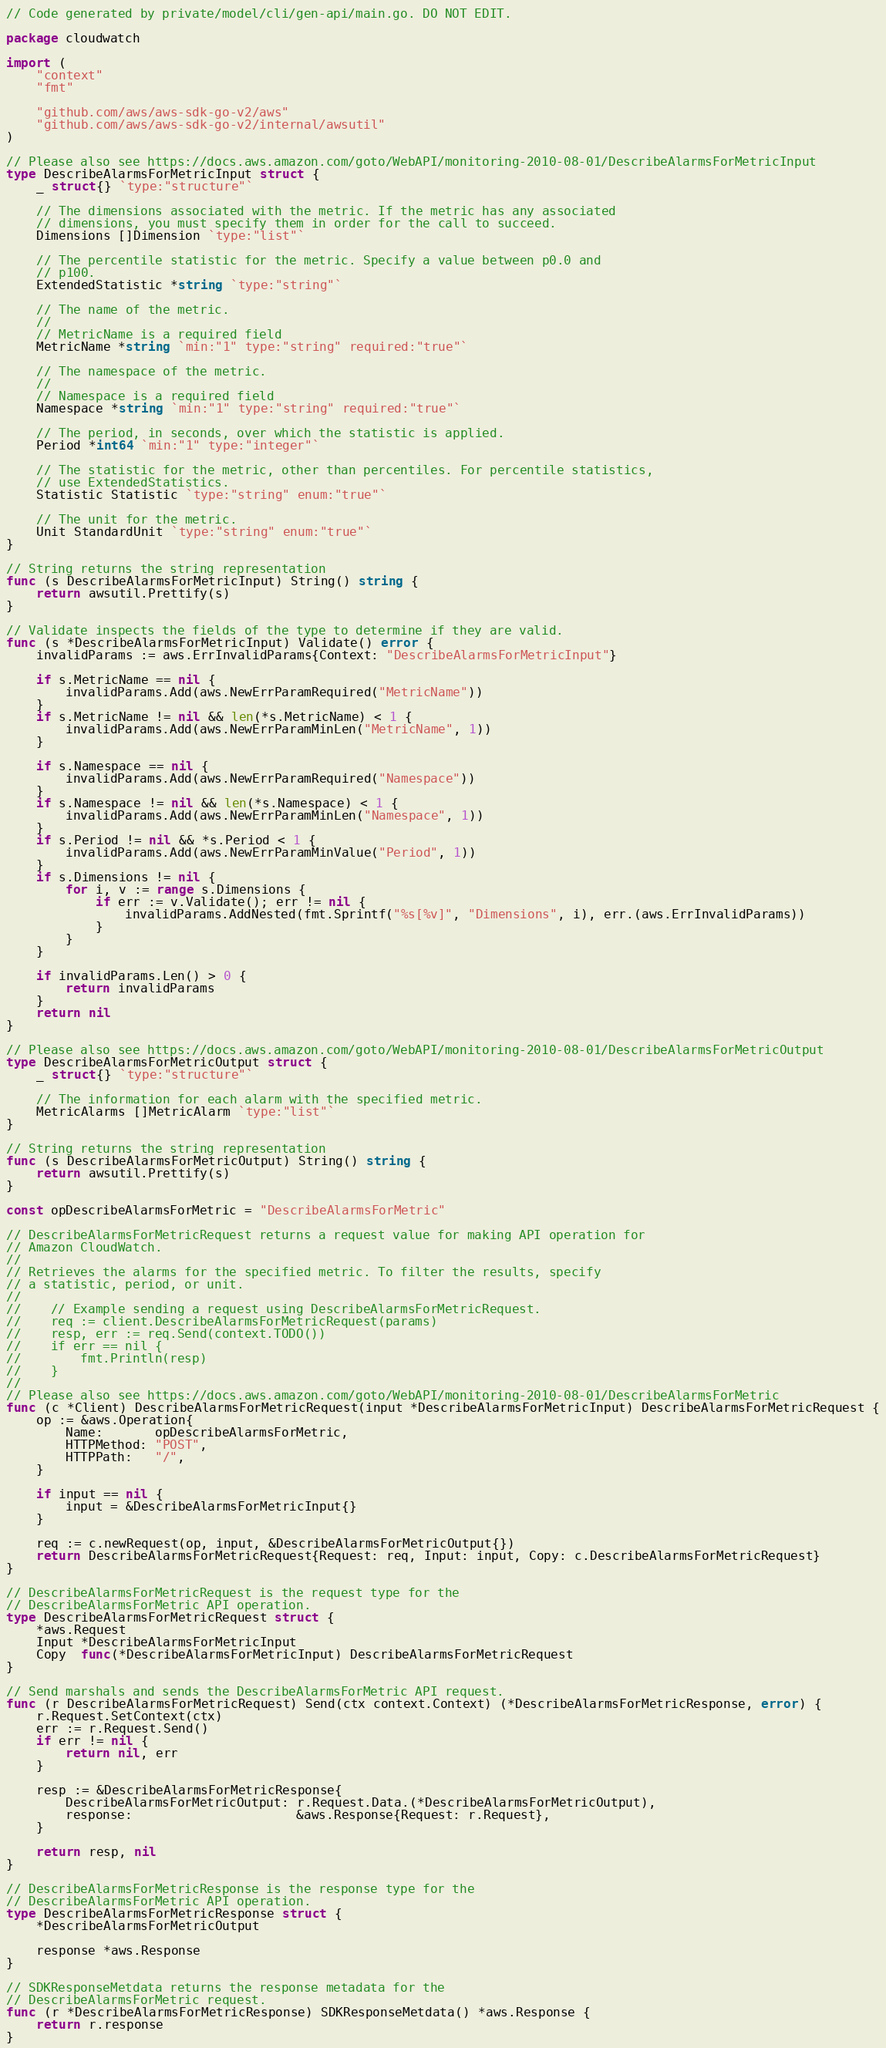<code> <loc_0><loc_0><loc_500><loc_500><_Go_>// Code generated by private/model/cli/gen-api/main.go. DO NOT EDIT.

package cloudwatch

import (
	"context"
	"fmt"

	"github.com/aws/aws-sdk-go-v2/aws"
	"github.com/aws/aws-sdk-go-v2/internal/awsutil"
)

// Please also see https://docs.aws.amazon.com/goto/WebAPI/monitoring-2010-08-01/DescribeAlarmsForMetricInput
type DescribeAlarmsForMetricInput struct {
	_ struct{} `type:"structure"`

	// The dimensions associated with the metric. If the metric has any associated
	// dimensions, you must specify them in order for the call to succeed.
	Dimensions []Dimension `type:"list"`

	// The percentile statistic for the metric. Specify a value between p0.0 and
	// p100.
	ExtendedStatistic *string `type:"string"`

	// The name of the metric.
	//
	// MetricName is a required field
	MetricName *string `min:"1" type:"string" required:"true"`

	// The namespace of the metric.
	//
	// Namespace is a required field
	Namespace *string `min:"1" type:"string" required:"true"`

	// The period, in seconds, over which the statistic is applied.
	Period *int64 `min:"1" type:"integer"`

	// The statistic for the metric, other than percentiles. For percentile statistics,
	// use ExtendedStatistics.
	Statistic Statistic `type:"string" enum:"true"`

	// The unit for the metric.
	Unit StandardUnit `type:"string" enum:"true"`
}

// String returns the string representation
func (s DescribeAlarmsForMetricInput) String() string {
	return awsutil.Prettify(s)
}

// Validate inspects the fields of the type to determine if they are valid.
func (s *DescribeAlarmsForMetricInput) Validate() error {
	invalidParams := aws.ErrInvalidParams{Context: "DescribeAlarmsForMetricInput"}

	if s.MetricName == nil {
		invalidParams.Add(aws.NewErrParamRequired("MetricName"))
	}
	if s.MetricName != nil && len(*s.MetricName) < 1 {
		invalidParams.Add(aws.NewErrParamMinLen("MetricName", 1))
	}

	if s.Namespace == nil {
		invalidParams.Add(aws.NewErrParamRequired("Namespace"))
	}
	if s.Namespace != nil && len(*s.Namespace) < 1 {
		invalidParams.Add(aws.NewErrParamMinLen("Namespace", 1))
	}
	if s.Period != nil && *s.Period < 1 {
		invalidParams.Add(aws.NewErrParamMinValue("Period", 1))
	}
	if s.Dimensions != nil {
		for i, v := range s.Dimensions {
			if err := v.Validate(); err != nil {
				invalidParams.AddNested(fmt.Sprintf("%s[%v]", "Dimensions", i), err.(aws.ErrInvalidParams))
			}
		}
	}

	if invalidParams.Len() > 0 {
		return invalidParams
	}
	return nil
}

// Please also see https://docs.aws.amazon.com/goto/WebAPI/monitoring-2010-08-01/DescribeAlarmsForMetricOutput
type DescribeAlarmsForMetricOutput struct {
	_ struct{} `type:"structure"`

	// The information for each alarm with the specified metric.
	MetricAlarms []MetricAlarm `type:"list"`
}

// String returns the string representation
func (s DescribeAlarmsForMetricOutput) String() string {
	return awsutil.Prettify(s)
}

const opDescribeAlarmsForMetric = "DescribeAlarmsForMetric"

// DescribeAlarmsForMetricRequest returns a request value for making API operation for
// Amazon CloudWatch.
//
// Retrieves the alarms for the specified metric. To filter the results, specify
// a statistic, period, or unit.
//
//    // Example sending a request using DescribeAlarmsForMetricRequest.
//    req := client.DescribeAlarmsForMetricRequest(params)
//    resp, err := req.Send(context.TODO())
//    if err == nil {
//        fmt.Println(resp)
//    }
//
// Please also see https://docs.aws.amazon.com/goto/WebAPI/monitoring-2010-08-01/DescribeAlarmsForMetric
func (c *Client) DescribeAlarmsForMetricRequest(input *DescribeAlarmsForMetricInput) DescribeAlarmsForMetricRequest {
	op := &aws.Operation{
		Name:       opDescribeAlarmsForMetric,
		HTTPMethod: "POST",
		HTTPPath:   "/",
	}

	if input == nil {
		input = &DescribeAlarmsForMetricInput{}
	}

	req := c.newRequest(op, input, &DescribeAlarmsForMetricOutput{})
	return DescribeAlarmsForMetricRequest{Request: req, Input: input, Copy: c.DescribeAlarmsForMetricRequest}
}

// DescribeAlarmsForMetricRequest is the request type for the
// DescribeAlarmsForMetric API operation.
type DescribeAlarmsForMetricRequest struct {
	*aws.Request
	Input *DescribeAlarmsForMetricInput
	Copy  func(*DescribeAlarmsForMetricInput) DescribeAlarmsForMetricRequest
}

// Send marshals and sends the DescribeAlarmsForMetric API request.
func (r DescribeAlarmsForMetricRequest) Send(ctx context.Context) (*DescribeAlarmsForMetricResponse, error) {
	r.Request.SetContext(ctx)
	err := r.Request.Send()
	if err != nil {
		return nil, err
	}

	resp := &DescribeAlarmsForMetricResponse{
		DescribeAlarmsForMetricOutput: r.Request.Data.(*DescribeAlarmsForMetricOutput),
		response:                      &aws.Response{Request: r.Request},
	}

	return resp, nil
}

// DescribeAlarmsForMetricResponse is the response type for the
// DescribeAlarmsForMetric API operation.
type DescribeAlarmsForMetricResponse struct {
	*DescribeAlarmsForMetricOutput

	response *aws.Response
}

// SDKResponseMetdata returns the response metadata for the
// DescribeAlarmsForMetric request.
func (r *DescribeAlarmsForMetricResponse) SDKResponseMetdata() *aws.Response {
	return r.response
}
</code> 